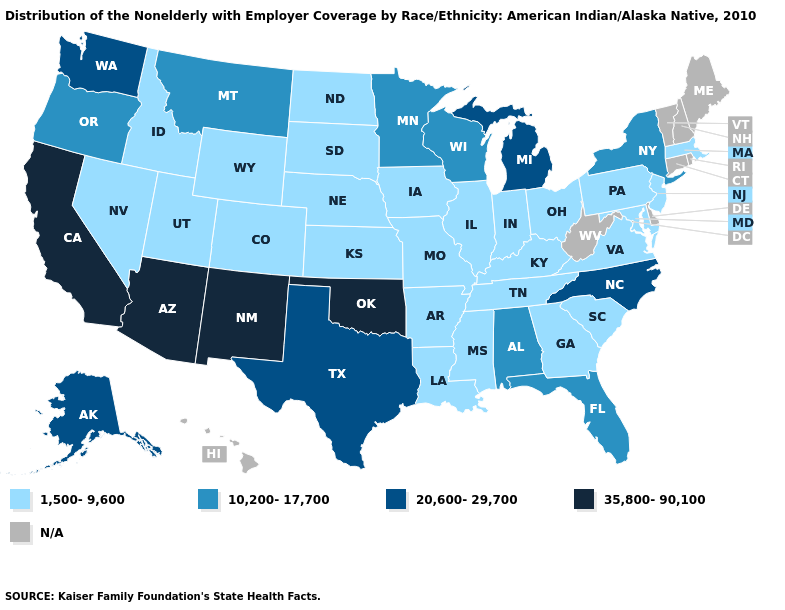Which states hav the highest value in the South?
Be succinct. Oklahoma. Among the states that border Ohio , does Pennsylvania have the highest value?
Quick response, please. No. Does the map have missing data?
Concise answer only. Yes. Which states hav the highest value in the MidWest?
Write a very short answer. Michigan. How many symbols are there in the legend?
Quick response, please. 5. Name the states that have a value in the range N/A?
Quick response, please. Connecticut, Delaware, Hawaii, Maine, New Hampshire, Rhode Island, Vermont, West Virginia. What is the value of Idaho?
Be succinct. 1,500-9,600. Name the states that have a value in the range 10,200-17,700?
Quick response, please. Alabama, Florida, Minnesota, Montana, New York, Oregon, Wisconsin. How many symbols are there in the legend?
Write a very short answer. 5. Does Minnesota have the lowest value in the MidWest?
Concise answer only. No. Name the states that have a value in the range 1,500-9,600?
Answer briefly. Arkansas, Colorado, Georgia, Idaho, Illinois, Indiana, Iowa, Kansas, Kentucky, Louisiana, Maryland, Massachusetts, Mississippi, Missouri, Nebraska, Nevada, New Jersey, North Dakota, Ohio, Pennsylvania, South Carolina, South Dakota, Tennessee, Utah, Virginia, Wyoming. What is the highest value in states that border Maryland?
Keep it brief. 1,500-9,600. Does the first symbol in the legend represent the smallest category?
Quick response, please. Yes. Name the states that have a value in the range 1,500-9,600?
Be succinct. Arkansas, Colorado, Georgia, Idaho, Illinois, Indiana, Iowa, Kansas, Kentucky, Louisiana, Maryland, Massachusetts, Mississippi, Missouri, Nebraska, Nevada, New Jersey, North Dakota, Ohio, Pennsylvania, South Carolina, South Dakota, Tennessee, Utah, Virginia, Wyoming. 